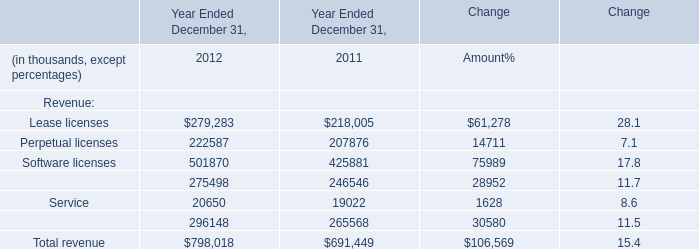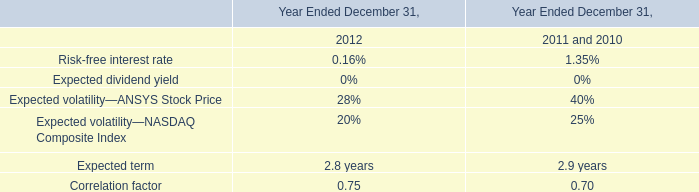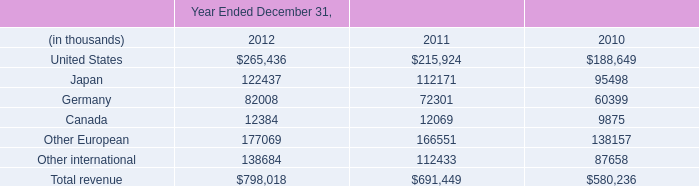What is the total amount of Service of Year Ended December 31, 2011, Other European of Year Ended December 31, 2010, and Japan of Year Ended December 31, 2010 ? 
Computations: ((19022.0 + 138157.0) + 95498.0)
Answer: 252677.0. 